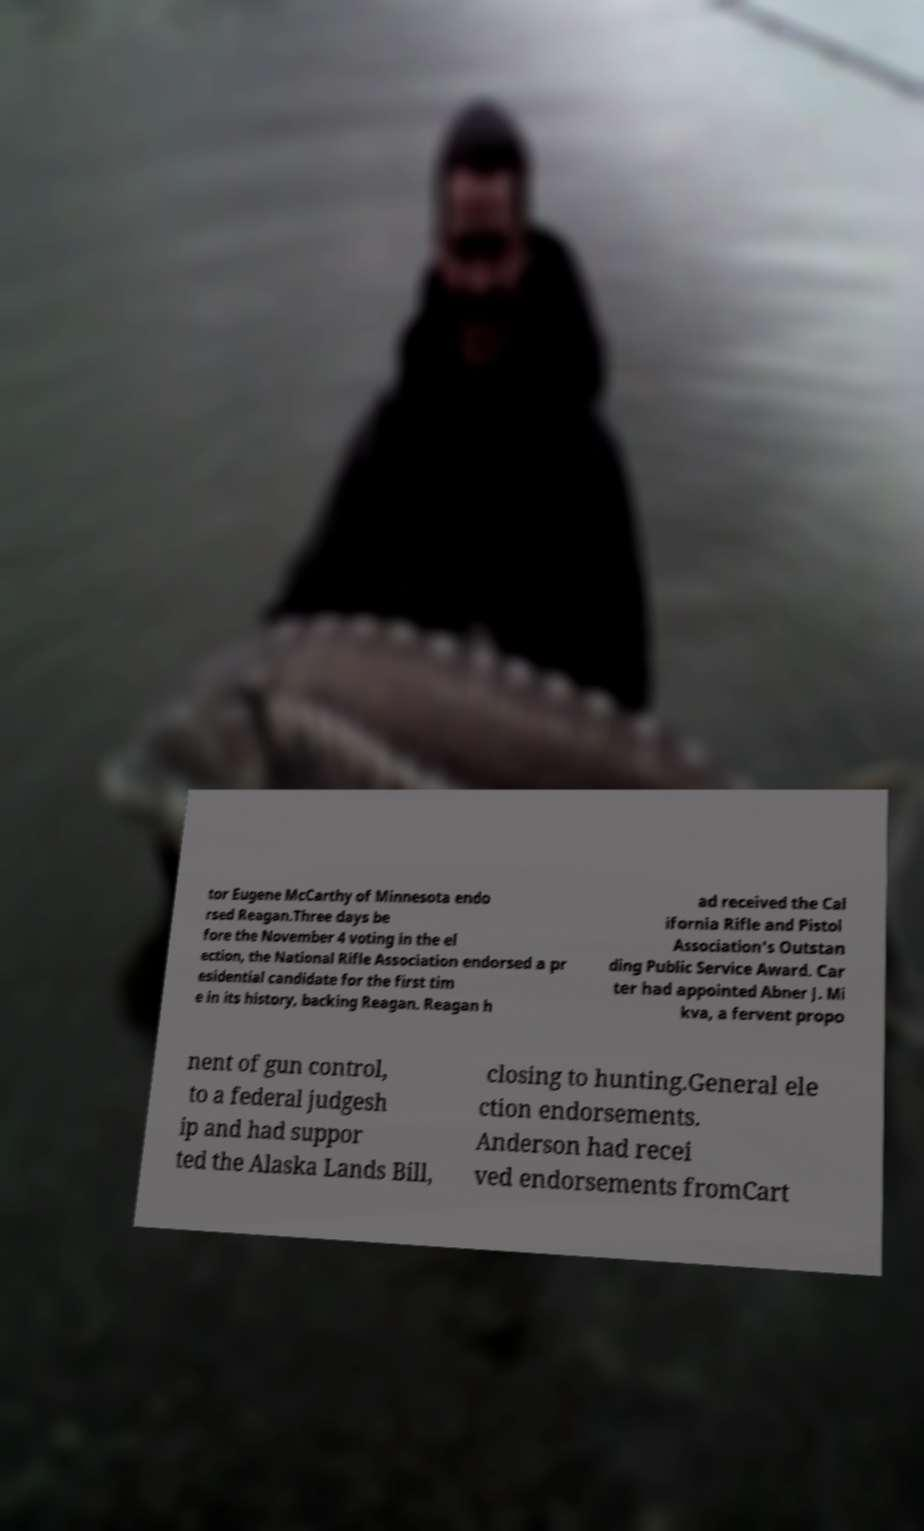There's text embedded in this image that I need extracted. Can you transcribe it verbatim? tor Eugene McCarthy of Minnesota endo rsed Reagan.Three days be fore the November 4 voting in the el ection, the National Rifle Association endorsed a pr esidential candidate for the first tim e in its history, backing Reagan. Reagan h ad received the Cal ifornia Rifle and Pistol Association's Outstan ding Public Service Award. Car ter had appointed Abner J. Mi kva, a fervent propo nent of gun control, to a federal judgesh ip and had suppor ted the Alaska Lands Bill, closing to hunting.General ele ction endorsements. Anderson had recei ved endorsements fromCart 